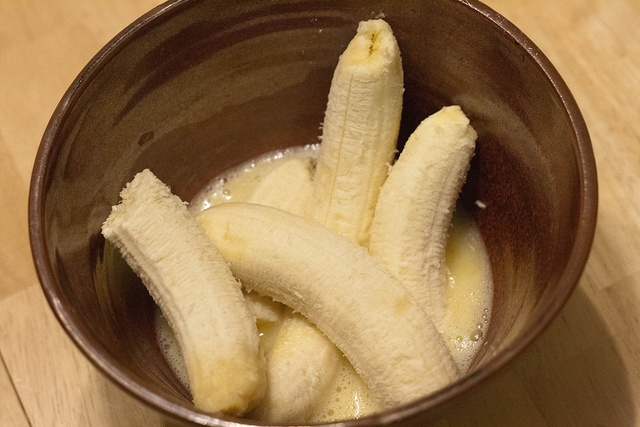Describe the objects in this image and their specific colors. I can see bowl in tan, maroon, and black tones, dining table in tan and maroon tones, banana in tan tones, banana in tan tones, and banana in tan tones in this image. 